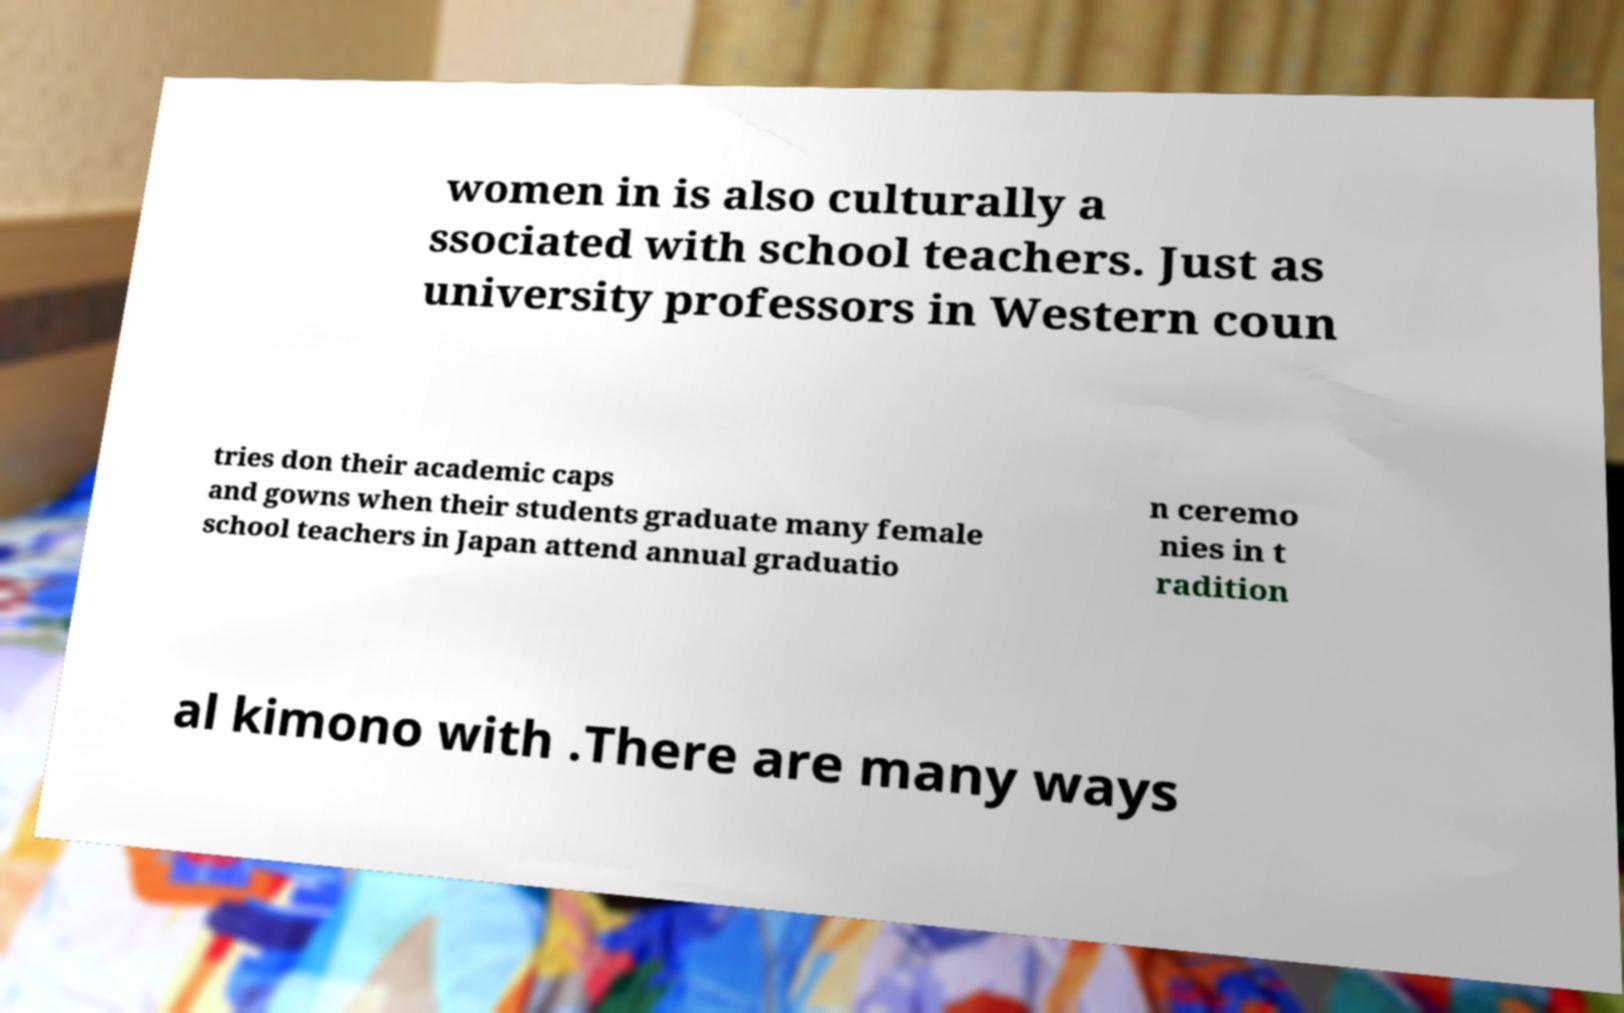I need the written content from this picture converted into text. Can you do that? women in is also culturally a ssociated with school teachers. Just as university professors in Western coun tries don their academic caps and gowns when their students graduate many female school teachers in Japan attend annual graduatio n ceremo nies in t radition al kimono with .There are many ways 